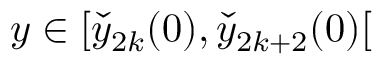<formula> <loc_0><loc_0><loc_500><loc_500>y \in [ \check { y } _ { 2 k } ( 0 ) , \check { y } _ { 2 k + 2 } ( 0 ) [</formula> 